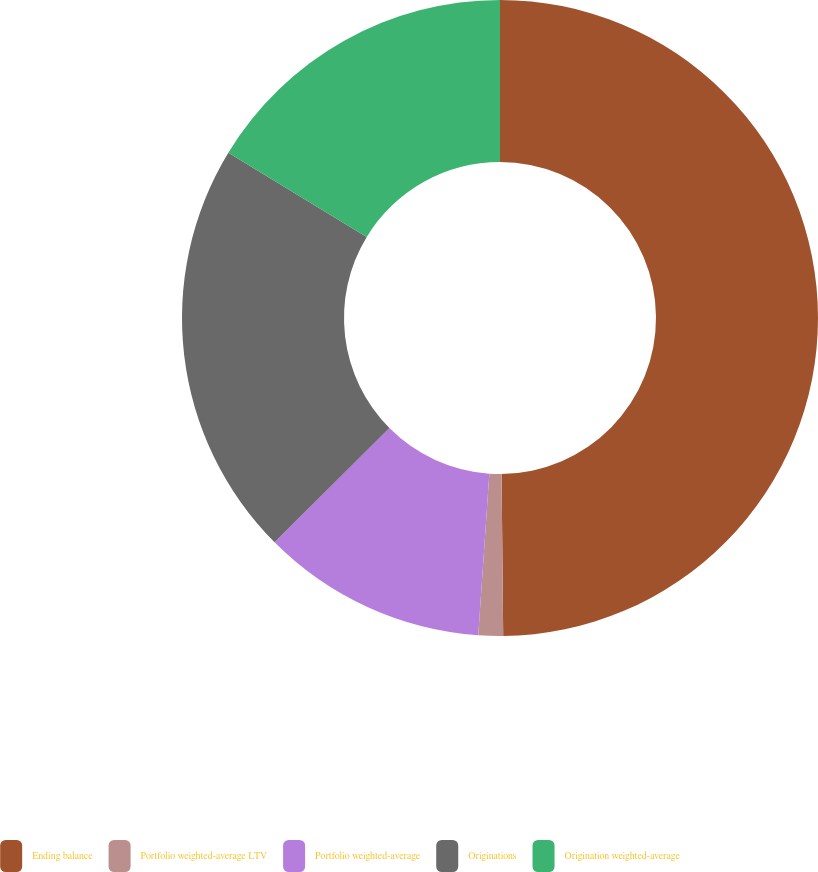Convert chart to OTSL. <chart><loc_0><loc_0><loc_500><loc_500><pie_chart><fcel>Ending balance<fcel>Portfolio weighted-average LTV<fcel>Portfolio weighted-average<fcel>Originations<fcel>Origination weighted-average<nl><fcel>49.84%<fcel>1.25%<fcel>11.45%<fcel>21.16%<fcel>16.3%<nl></chart> 